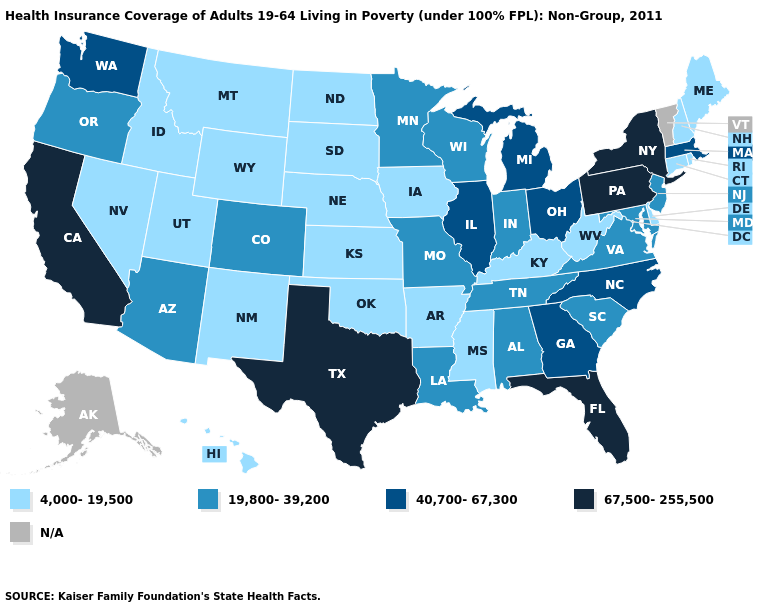What is the value of Tennessee?
Answer briefly. 19,800-39,200. Does Texas have the highest value in the USA?
Short answer required. Yes. Which states have the lowest value in the West?
Write a very short answer. Hawaii, Idaho, Montana, Nevada, New Mexico, Utah, Wyoming. What is the lowest value in states that border Nebraska?
Be succinct. 4,000-19,500. What is the value of Maryland?
Give a very brief answer. 19,800-39,200. Which states have the lowest value in the South?
Give a very brief answer. Arkansas, Delaware, Kentucky, Mississippi, Oklahoma, West Virginia. Does the map have missing data?
Give a very brief answer. Yes. What is the value of Iowa?
Short answer required. 4,000-19,500. What is the lowest value in the USA?
Short answer required. 4,000-19,500. Does New Mexico have the lowest value in the USA?
Quick response, please. Yes. Name the states that have a value in the range 67,500-255,500?
Quick response, please. California, Florida, New York, Pennsylvania, Texas. Name the states that have a value in the range N/A?
Be succinct. Alaska, Vermont. Does the map have missing data?
Be succinct. Yes. Among the states that border Nevada , which have the highest value?
Short answer required. California. Name the states that have a value in the range N/A?
Concise answer only. Alaska, Vermont. 